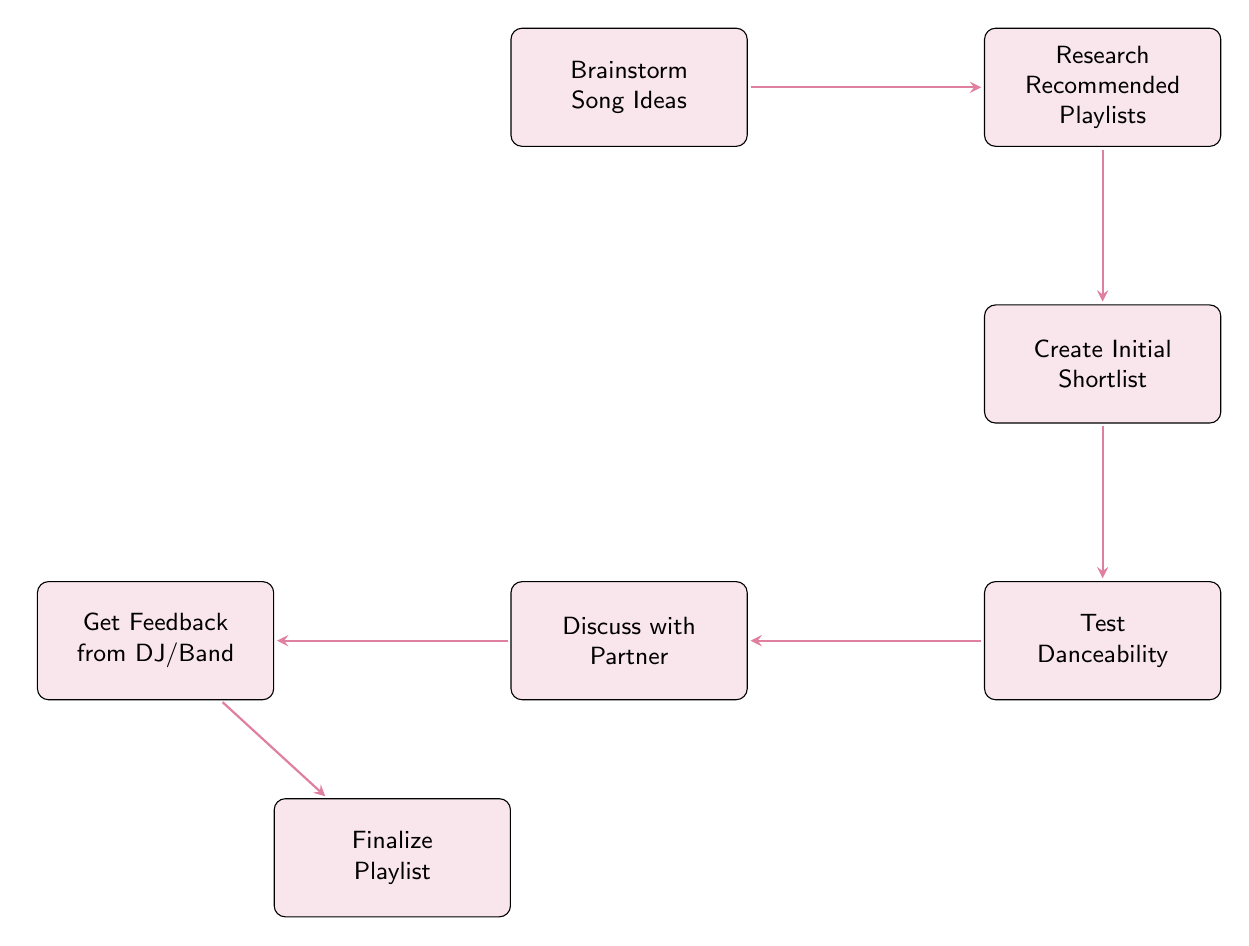What is the first step in the diagram? The first step is represented by the node "Brainstorm Song Ideas," which indicates gathering suggestions from various sources.
Answer: Brainstorm Song Ideas How many nodes are in the diagram? Counting all the distinct steps from the diagram shows there are seven nodes.
Answer: 7 What is the last step before finalizing the playlist? The last step before finalizing the playlist is "Get Feedback from DJ/Band," where professionals provide input on the selected songs.
Answer: Get Feedback from DJ/Band Which node comes immediately after "Research Recommended Playlists"? Following "Research Recommended Playlists," the next node is "Create Initial Shortlist," which involves narrowing down song options.
Answer: Create Initial Shortlist Which two steps directly involve discussing with others? The steps "Discuss with Partner" and "Get Feedback from DJ/Band" both involve discussing selection with other people to gather opinions.
Answer: Discuss with Partner and Get Feedback from DJ/Band What is the primary action taken after creating the initial shortlist? After creating the initial shortlist, the next primary action is to "Test Danceability," which is about physically trying out the songs.
Answer: Test Danceability What type of feedback is sought in the step before finalizing the playlist? The feedback sought is from a DJ or band, which provides professional perspectives on the selected songs' suitability.
Answer: Professional input How many arrows connect the nodes? Each connection is represented by an arrow, and there are six arrows connecting the seven nodes, indicating the flow from one step to another.
Answer: 6 